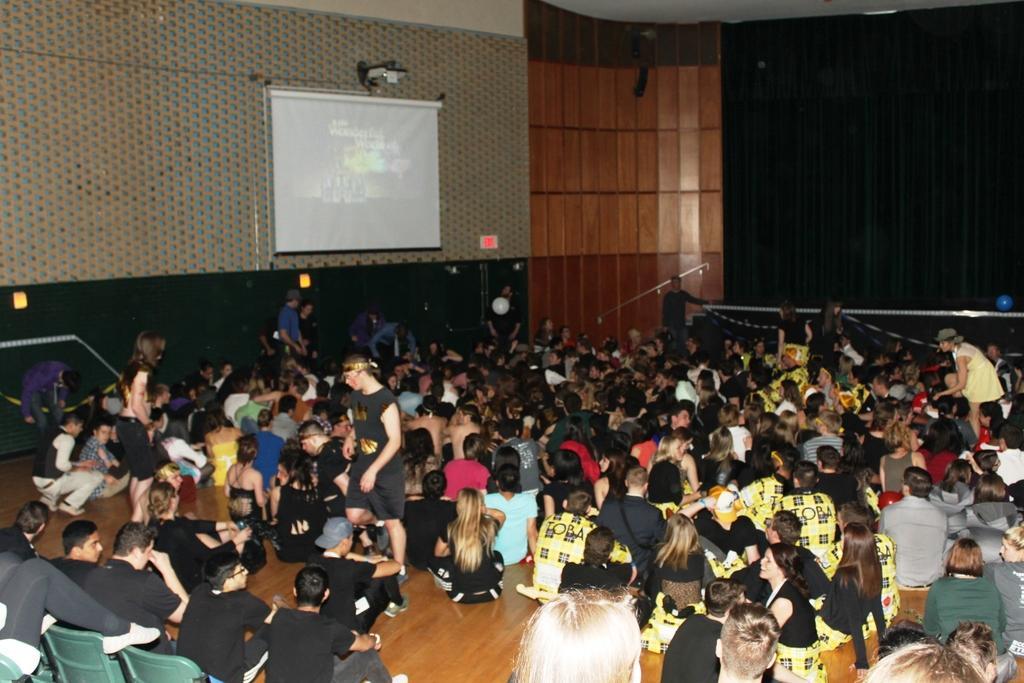In one or two sentences, can you explain what this image depicts? In this image there are people sitting on the floor. Few people are standing on the floor. Left bottom there are people sitting on the chairs. A screen is attached to the wall. Right side there are curtains. 